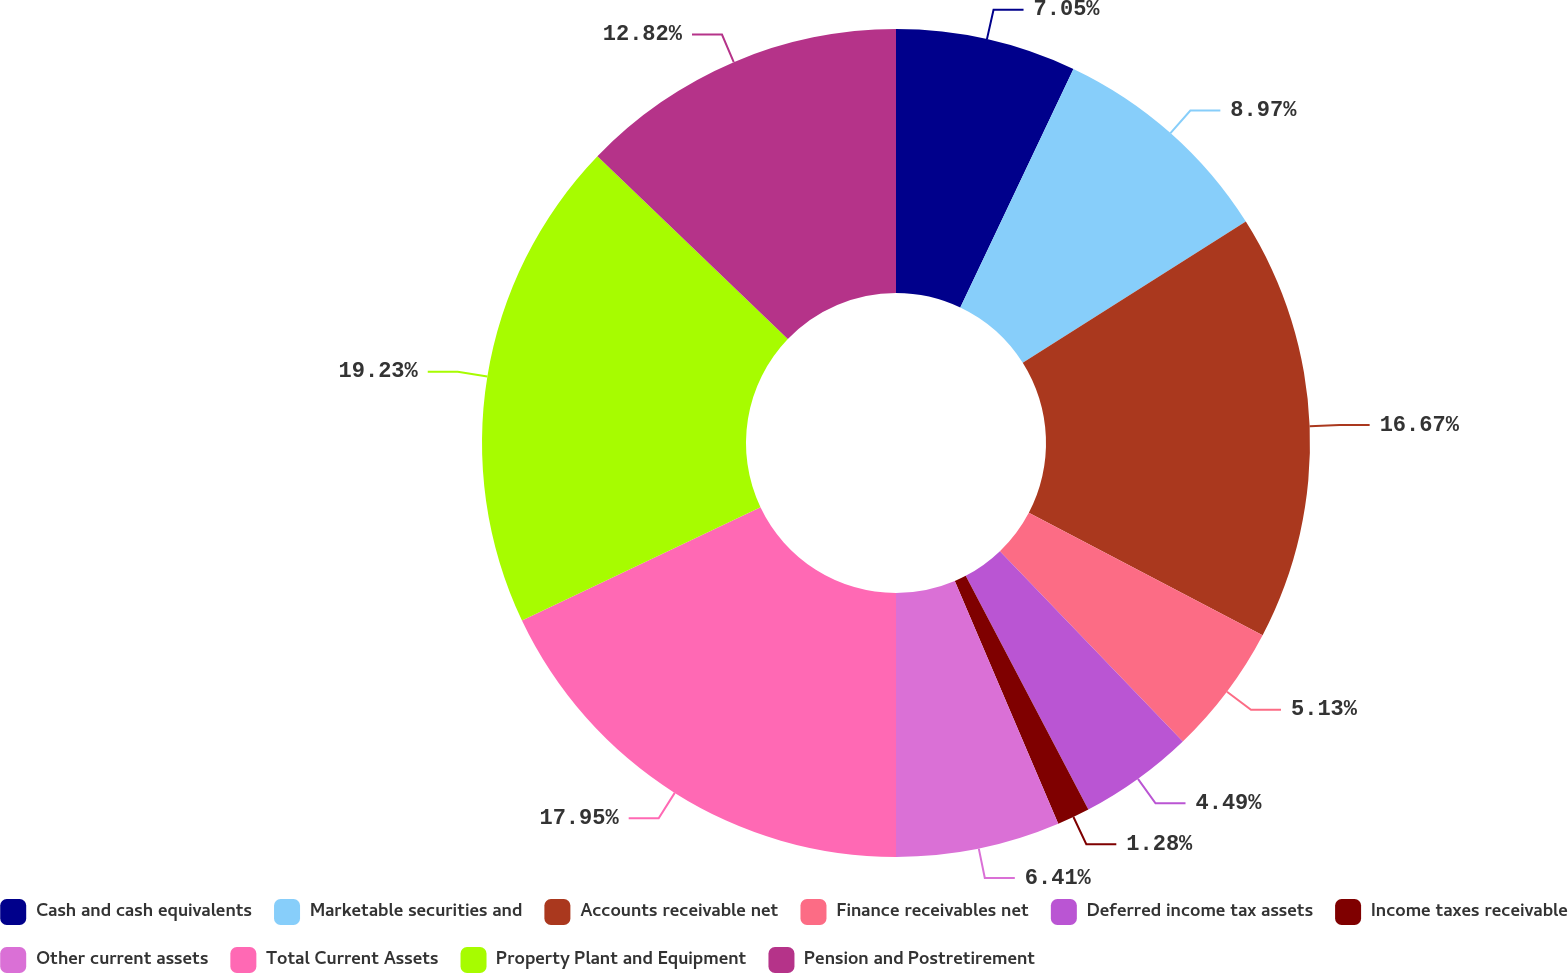<chart> <loc_0><loc_0><loc_500><loc_500><pie_chart><fcel>Cash and cash equivalents<fcel>Marketable securities and<fcel>Accounts receivable net<fcel>Finance receivables net<fcel>Deferred income tax assets<fcel>Income taxes receivable<fcel>Other current assets<fcel>Total Current Assets<fcel>Property Plant and Equipment<fcel>Pension and Postretirement<nl><fcel>7.05%<fcel>8.97%<fcel>16.67%<fcel>5.13%<fcel>4.49%<fcel>1.28%<fcel>6.41%<fcel>17.95%<fcel>19.23%<fcel>12.82%<nl></chart> 